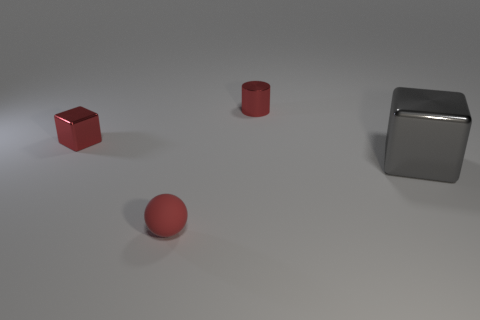There is a small sphere that is the same color as the tiny metal cylinder; what is it made of?
Give a very brief answer. Rubber. Is the number of small balls behind the small cube less than the number of small red matte spheres that are right of the metallic cylinder?
Offer a terse response. No. There is a metallic cube that is to the right of the small red object behind the cube behind the large metallic object; what is its size?
Provide a succinct answer. Large. Do the block that is behind the gray cube and the tiny red sphere have the same size?
Provide a short and direct response. Yes. What number of other things are made of the same material as the red ball?
Offer a very short reply. 0. Is the number of big rubber things greater than the number of shiny objects?
Offer a very short reply. No. The block that is on the left side of the red metallic thing right of the red metallic object that is on the left side of the small cylinder is made of what material?
Give a very brief answer. Metal. Is the color of the rubber object the same as the metallic cylinder?
Your answer should be compact. Yes. Are there any matte objects that have the same color as the tiny sphere?
Offer a very short reply. No. What is the shape of the red matte thing that is the same size as the red metal block?
Your answer should be compact. Sphere. 